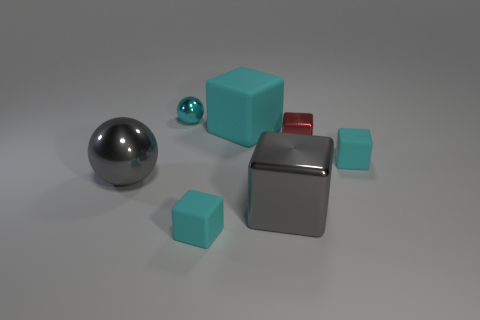Is the number of gray things less than the number of big gray metallic balls?
Offer a terse response. No. Do the red object and the gray metallic object to the right of the tiny cyan metal object have the same size?
Your answer should be compact. No. Is there anything else that has the same shape as the big cyan matte object?
Your answer should be compact. Yes. The red metallic cube is what size?
Make the answer very short. Small. Are there fewer small shiny cubes in front of the gray metal sphere than large purple balls?
Your answer should be compact. No. Is the size of the gray sphere the same as the red shiny object?
Ensure brevity in your answer.  No. Is there anything else that has the same size as the red thing?
Provide a short and direct response. Yes. What color is the other ball that is the same material as the tiny sphere?
Provide a succinct answer. Gray. Is the number of matte cubes that are to the left of the small red block less than the number of tiny shiny things that are left of the big cyan block?
Your answer should be very brief. No. What number of big things are the same color as the big metal sphere?
Offer a terse response. 1. 